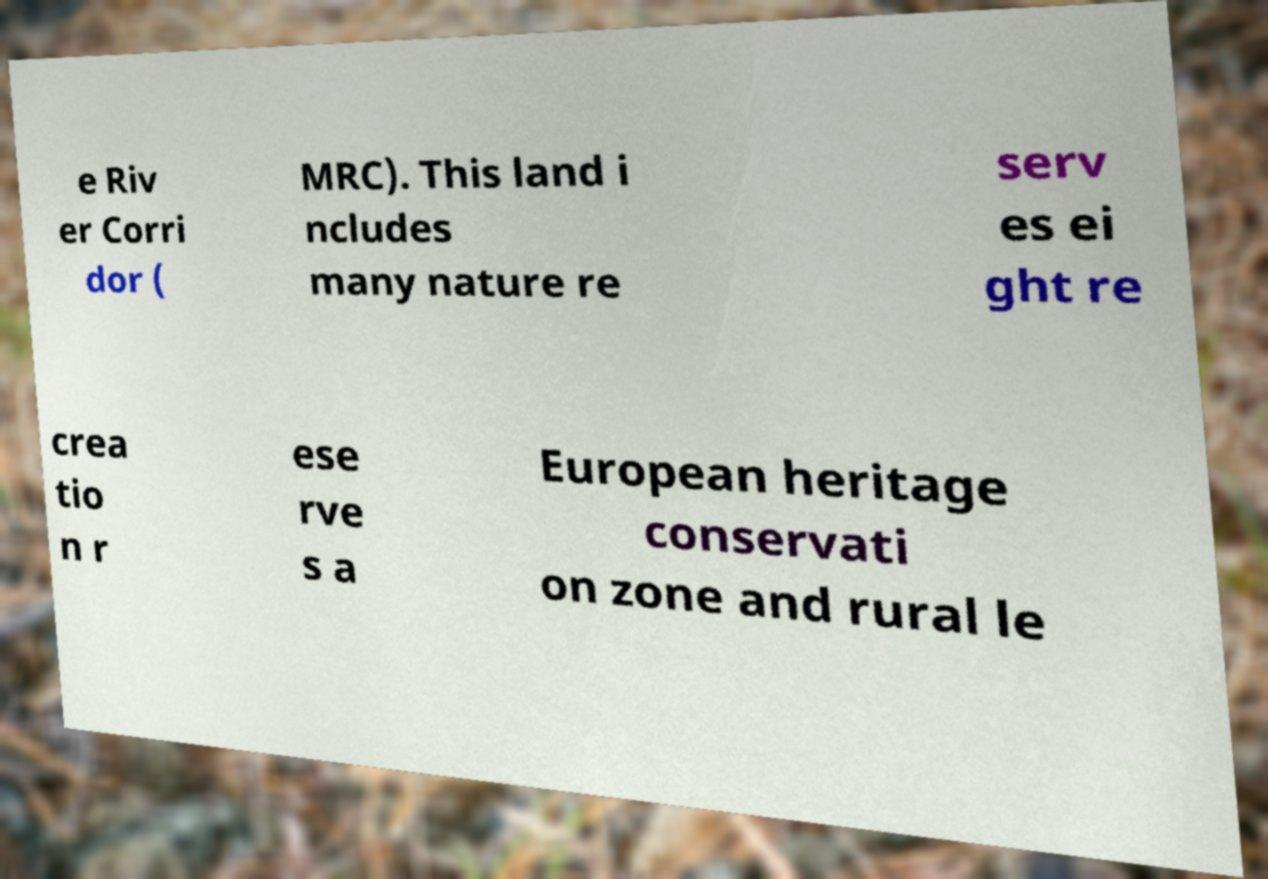I need the written content from this picture converted into text. Can you do that? e Riv er Corri dor ( MRC). This land i ncludes many nature re serv es ei ght re crea tio n r ese rve s a European heritage conservati on zone and rural le 